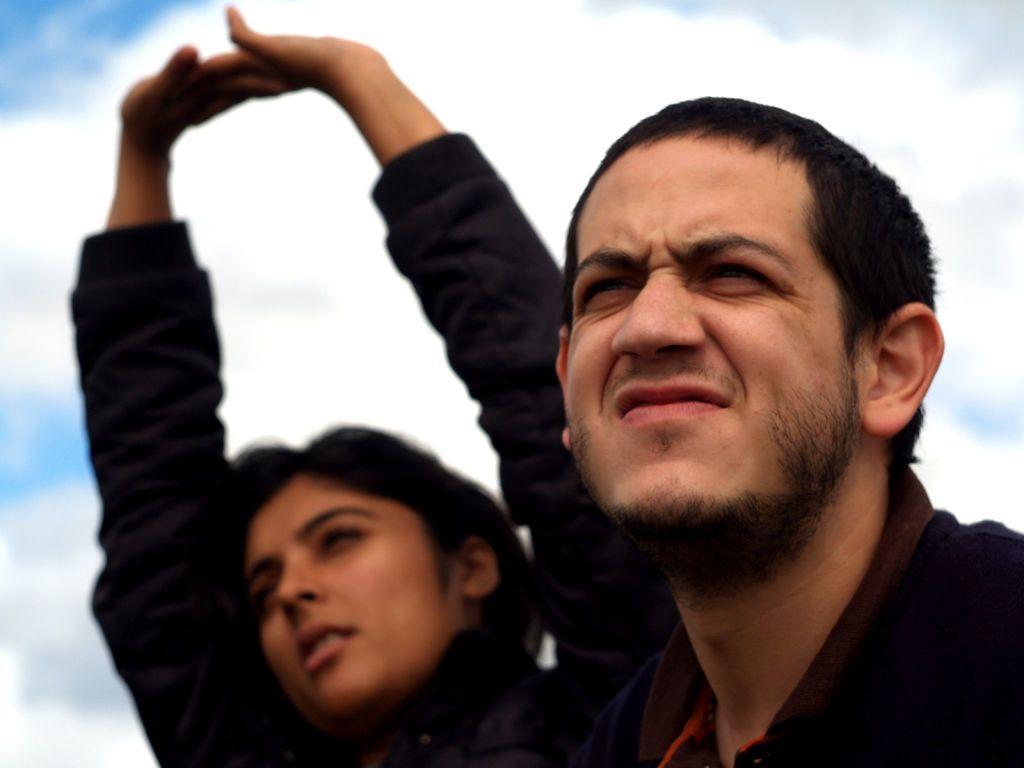Describe this image in one or two sentences. In this image we can see two persons wearing dress. In the background, we can see the cloudy sky. 